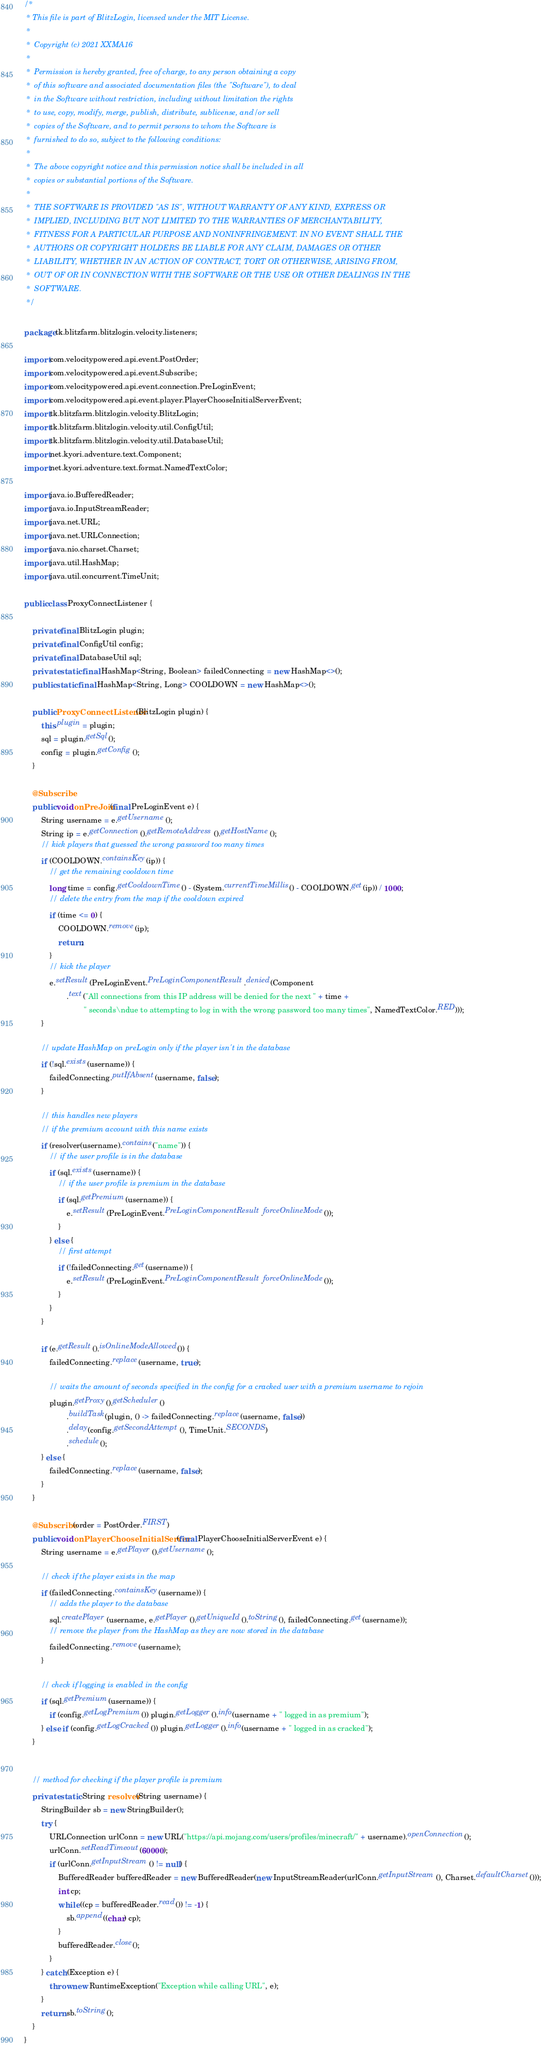<code> <loc_0><loc_0><loc_500><loc_500><_Java_>/*
 * This file is part of BlitzLogin, licensed under the MIT License.
 *
 *  Copyright (c) 2021 XXMA16
 *
 *  Permission is hereby granted, free of charge, to any person obtaining a copy
 *  of this software and associated documentation files (the "Software"), to deal
 *  in the Software without restriction, including without limitation the rights
 *  to use, copy, modify, merge, publish, distribute, sublicense, and/or sell
 *  copies of the Software, and to permit persons to whom the Software is
 *  furnished to do so, subject to the following conditions:
 *
 *  The above copyright notice and this permission notice shall be included in all
 *  copies or substantial portions of the Software.
 *
 *  THE SOFTWARE IS PROVIDED "AS IS", WITHOUT WARRANTY OF ANY KIND, EXPRESS OR
 *  IMPLIED, INCLUDING BUT NOT LIMITED TO THE WARRANTIES OF MERCHANTABILITY,
 *  FITNESS FOR A PARTICULAR PURPOSE AND NONINFRINGEMENT. IN NO EVENT SHALL THE
 *  AUTHORS OR COPYRIGHT HOLDERS BE LIABLE FOR ANY CLAIM, DAMAGES OR OTHER
 *  LIABILITY, WHETHER IN AN ACTION OF CONTRACT, TORT OR OTHERWISE, ARISING FROM,
 *  OUT OF OR IN CONNECTION WITH THE SOFTWARE OR THE USE OR OTHER DEALINGS IN THE
 *  SOFTWARE.
 */

package tk.blitzfarm.blitzlogin.velocity.listeners;

import com.velocitypowered.api.event.PostOrder;
import com.velocitypowered.api.event.Subscribe;
import com.velocitypowered.api.event.connection.PreLoginEvent;
import com.velocitypowered.api.event.player.PlayerChooseInitialServerEvent;
import tk.blitzfarm.blitzlogin.velocity.BlitzLogin;
import tk.blitzfarm.blitzlogin.velocity.util.ConfigUtil;
import tk.blitzfarm.blitzlogin.velocity.util.DatabaseUtil;
import net.kyori.adventure.text.Component;
import net.kyori.adventure.text.format.NamedTextColor;

import java.io.BufferedReader;
import java.io.InputStreamReader;
import java.net.URL;
import java.net.URLConnection;
import java.nio.charset.Charset;
import java.util.HashMap;
import java.util.concurrent.TimeUnit;

public class ProxyConnectListener {

    private final BlitzLogin plugin;
    private final ConfigUtil config;
    private final DatabaseUtil sql;
    private static final HashMap<String, Boolean> failedConnecting = new HashMap<>();
    public static final HashMap<String, Long> COOLDOWN = new HashMap<>();

    public ProxyConnectListener(BlitzLogin plugin) {
        this.plugin = plugin;
        sql = plugin.getSql();
        config = plugin.getConfig();
    }

    @Subscribe
    public void onPreJoin(final PreLoginEvent e) {
        String username = e.getUsername();
        String ip = e.getConnection().getRemoteAddress().getHostName();
        // kick players that guessed the wrong password too many times
        if (COOLDOWN.containsKey(ip)) {
            // get the remaining cooldown time
            long time = config.getCooldownTime() - (System.currentTimeMillis() - COOLDOWN.get(ip)) / 1000;
            // delete the entry from the map if the cooldown expired
            if (time <= 0) {
                COOLDOWN.remove(ip);
                return;
            }
            // kick the player
            e.setResult(PreLoginEvent.PreLoginComponentResult.denied(Component
                    .text("All connections from this IP address will be denied for the next " + time +
                            " seconds\ndue to attempting to log in with the wrong password too many times", NamedTextColor.RED)));
        }

        // update HashMap on preLogin only if the player isn't in the database
        if (!sql.exists(username)) {
            failedConnecting.putIfAbsent(username, false);
        }

        // this handles new players
        // if the premium account with this name exists
        if (resolver(username).contains("name")) {
            // if the user profile is in the database
            if (sql.exists(username)) {
                // if the user profile is premium in the database
                if (sql.getPremium(username)) {
                    e.setResult(PreLoginEvent.PreLoginComponentResult.forceOnlineMode());
                }
            } else {
                // first attempt
                if (!failedConnecting.get(username)) {
                    e.setResult(PreLoginEvent.PreLoginComponentResult.forceOnlineMode());
                }
            }
        }

        if (e.getResult().isOnlineModeAllowed()) {
            failedConnecting.replace(username, true);

            // waits the amount of seconds specified in the config for a cracked user with a premium username to rejoin
            plugin.getProxy().getScheduler()
                    .buildTask(plugin, () -> failedConnecting.replace(username, false))
                    .delay(config.getSecondAttempt(), TimeUnit.SECONDS)
                    .schedule();
        } else {
            failedConnecting.replace(username, false);
        }
    }

    @Subscribe(order = PostOrder.FIRST)
    public void onPlayerChooseInitialServer(final PlayerChooseInitialServerEvent e) {
        String username = e.getPlayer().getUsername();

        // check if the player exists in the map
        if (failedConnecting.containsKey(username)) {
            // adds the player to the database
            sql.createPlayer(username, e.getPlayer().getUniqueId().toString(), failedConnecting.get(username));
            // remove the player from the HashMap as they are now stored in the database
            failedConnecting.remove(username);
        }

        // check if logging is enabled in the config
        if (sql.getPremium(username)) {
            if (config.getLogPremium()) plugin.getLogger().info(username + " logged in as premium");
        } else if (config.getLogCracked()) plugin.getLogger().info(username + " logged in as cracked");
    }


    // method for checking if the player profile is premium
    private static String resolver(String username) {
        StringBuilder sb = new StringBuilder();
        try {
            URLConnection urlConn = new URL("https://api.mojang.com/users/profiles/minecraft/" + username).openConnection();
            urlConn.setReadTimeout(60000);
            if (urlConn.getInputStream() != null) {
                BufferedReader bufferedReader = new BufferedReader(new InputStreamReader(urlConn.getInputStream(), Charset.defaultCharset()));
                int cp;
                while ((cp = bufferedReader.read()) != -1) {
                    sb.append((char) cp);
                }
                bufferedReader.close();
            }
        } catch (Exception e) {
            throw new RuntimeException("Exception while calling URL", e);
        }
        return sb.toString();
    }
}
</code> 